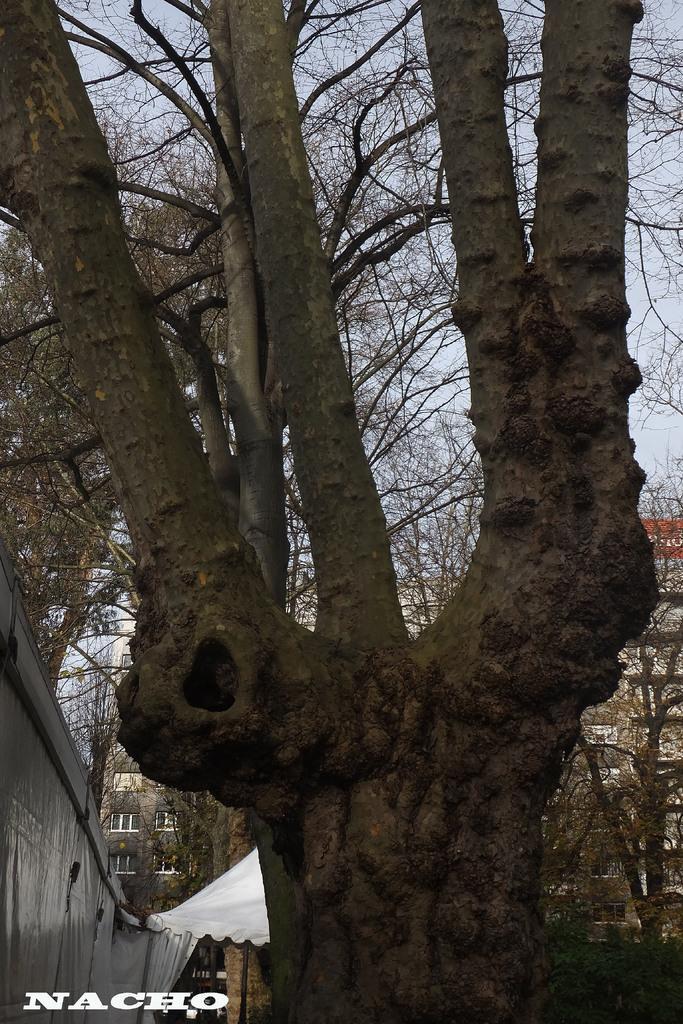Describe this image in one or two sentences. In this image there is a tree trunk in the middle. On the left side there is a wall. In the background there is a white color tint. Behind the text there are buildings. At the top there is the sky. 